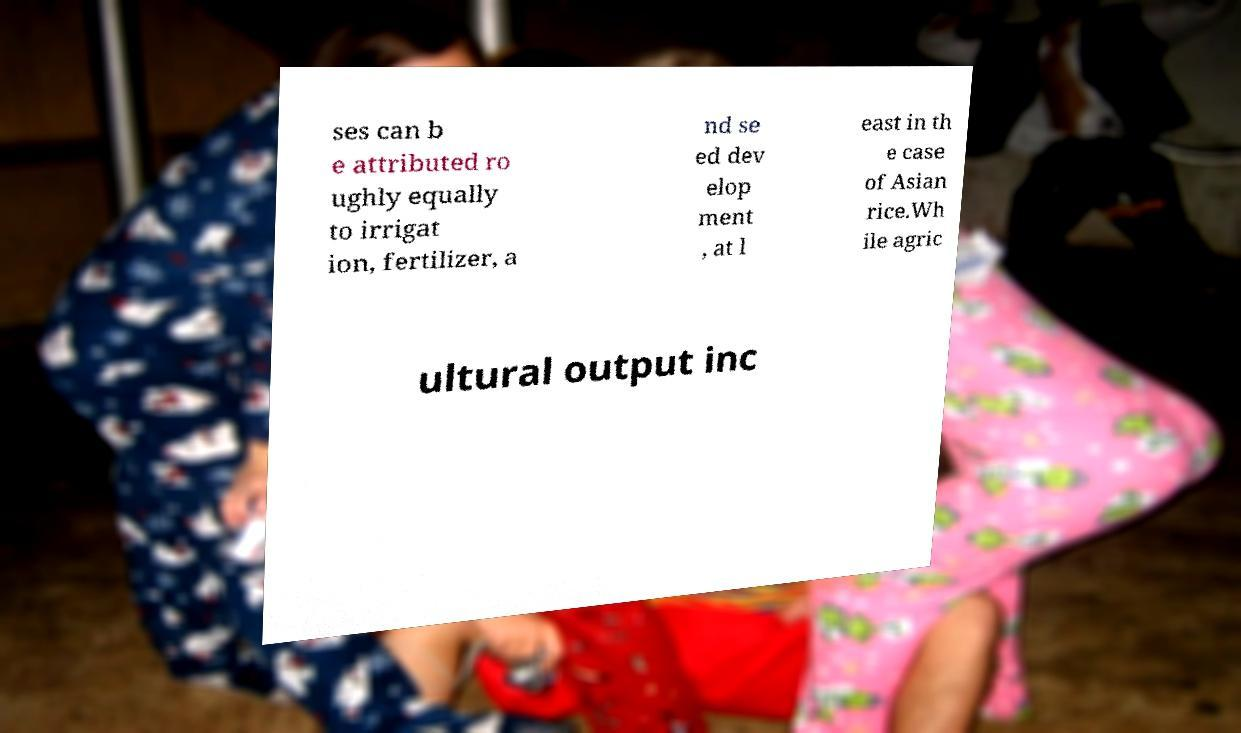For documentation purposes, I need the text within this image transcribed. Could you provide that? ses can b e attributed ro ughly equally to irrigat ion, fertilizer, a nd se ed dev elop ment , at l east in th e case of Asian rice.Wh ile agric ultural output inc 